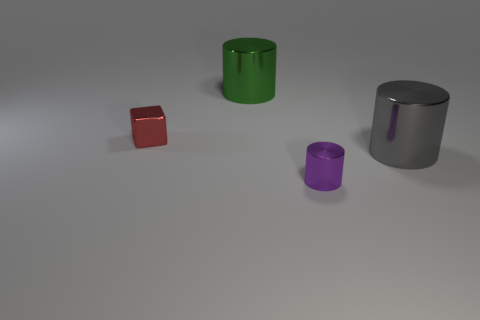Is the material of the large cylinder in front of the tiny red object the same as the object on the left side of the green metallic cylinder?
Provide a short and direct response. Yes. What number of objects are metal cylinders behind the small red thing or red metal cylinders?
Give a very brief answer. 1. Are there fewer metal cubes that are in front of the purple shiny thing than large green shiny objects left of the gray thing?
Keep it short and to the point. Yes. What number of other objects are there of the same size as the green cylinder?
Offer a terse response. 1. Is the gray object made of the same material as the cylinder behind the large gray shiny thing?
Your response must be concise. Yes. How many things are either big metal objects that are to the right of the green metal cylinder or large shiny cylinders that are in front of the big green object?
Provide a succinct answer. 1. The tiny cylinder is what color?
Your response must be concise. Purple. Are there fewer small blocks on the left side of the shiny block than purple cylinders?
Give a very brief answer. Yes. Are there any other things that are the same shape as the green thing?
Offer a very short reply. Yes. Are any green metal objects visible?
Keep it short and to the point. Yes. 